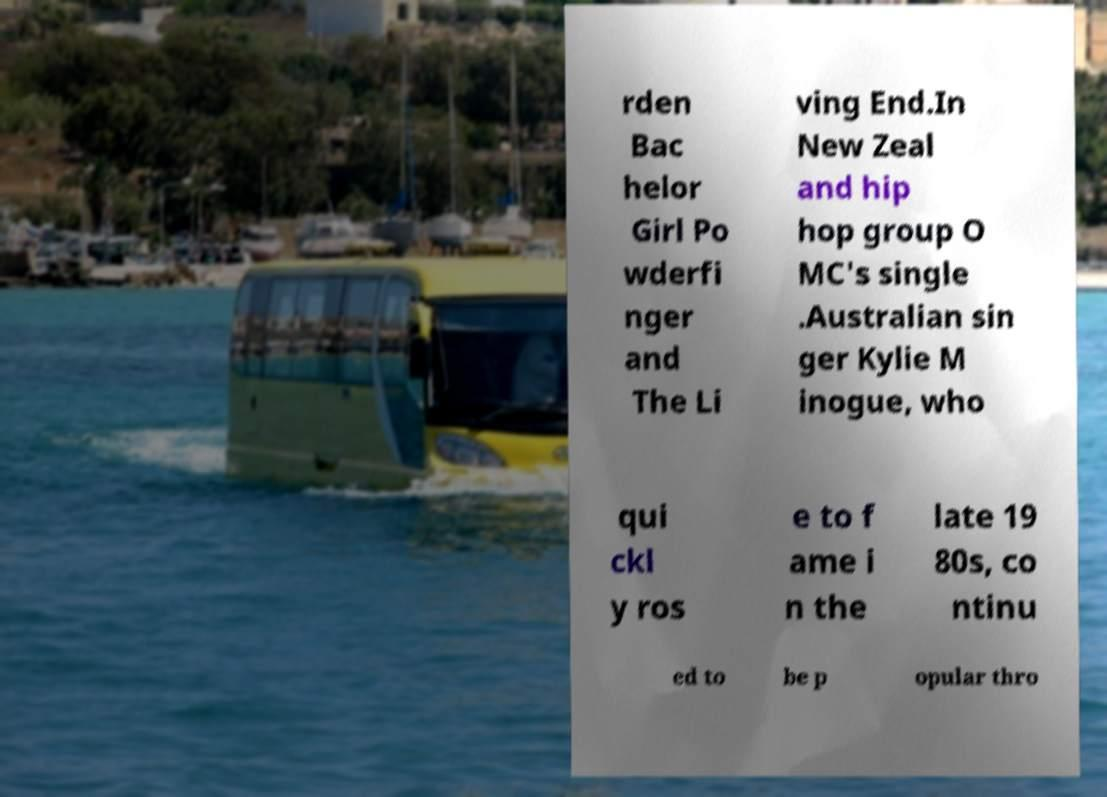Please identify and transcribe the text found in this image. rden Bac helor Girl Po wderfi nger and The Li ving End.In New Zeal and hip hop group O MC's single .Australian sin ger Kylie M inogue, who qui ckl y ros e to f ame i n the late 19 80s, co ntinu ed to be p opular thro 